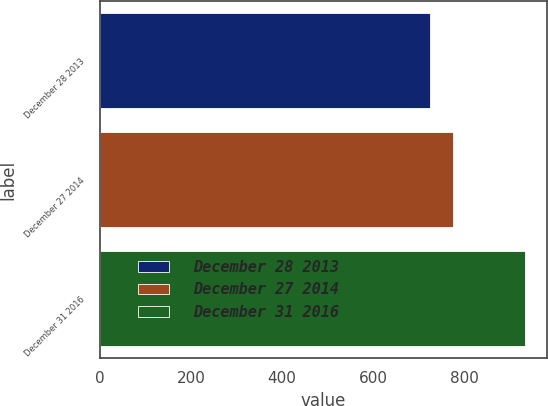Convert chart. <chart><loc_0><loc_0><loc_500><loc_500><bar_chart><fcel>December 28 2013<fcel>December 27 2014<fcel>December 31 2016<nl><fcel>725<fcel>776<fcel>935<nl></chart> 